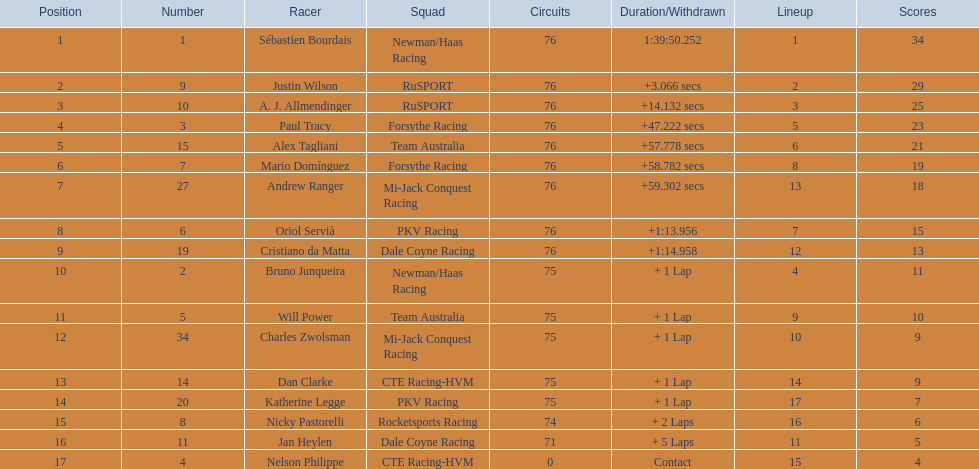Who drove during the 2006 tecate grand prix of monterrey? Sébastien Bourdais, Justin Wilson, A. J. Allmendinger, Paul Tracy, Alex Tagliani, Mario Domínguez, Andrew Ranger, Oriol Servià, Cristiano da Matta, Bruno Junqueira, Will Power, Charles Zwolsman, Dan Clarke, Katherine Legge, Nicky Pastorelli, Jan Heylen, Nelson Philippe. And what were their finishing positions? 1, 2, 3, 4, 5, 6, 7, 8, 9, 10, 11, 12, 13, 14, 15, 16, 17. Who did alex tagliani finish directly behind of? Paul Tracy. 